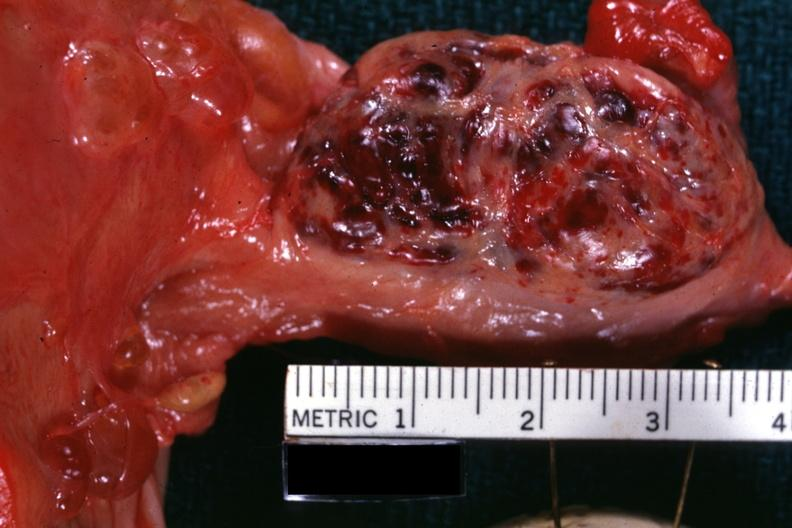s papillary adenoma present?
Answer the question using a single word or phrase. No 